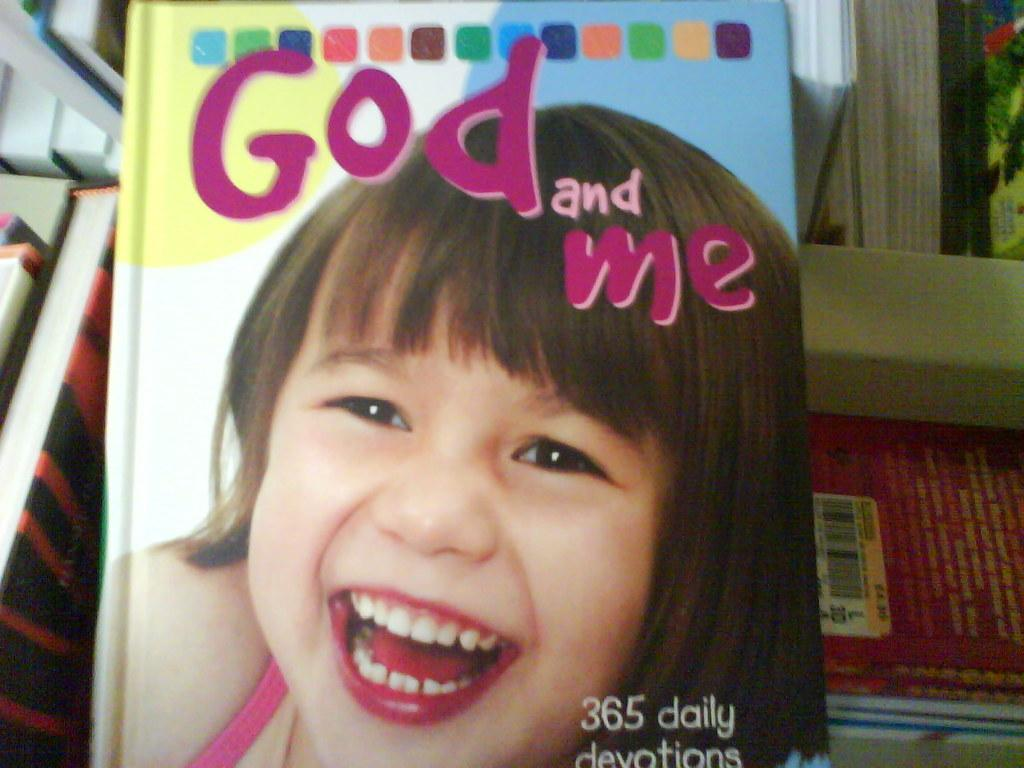What is the main object in the image? There is a book with text in the image. What can be seen on the cover of the book? The book has an image of a person. Can you describe the background of the image? In the background of the image, there are books visible on a shelf. What type of stick is being used to carry the carriage in the image? There is no stick or carriage present in the image; it features a book with text and an image of a person. 